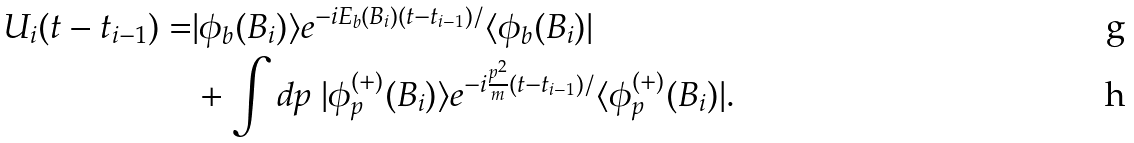Convert formula to latex. <formula><loc_0><loc_0><loc_500><loc_500>U _ { i } ( t - t _ { i - 1 } ) = & | \phi _ { b } ( B _ { i } ) \rangle e ^ { - i E _ { b } ( B _ { i } ) ( t - t _ { i - 1 } ) / } \langle \phi _ { b } ( B _ { i } ) | \\ & + \int d p \ | \phi _ { p } ^ { ( + ) } ( B _ { i } ) \rangle e ^ { - i \frac { p ^ { 2 } } { m } ( t - t _ { i - 1 } ) / } \langle \phi _ { p } ^ { ( + ) } ( B _ { i } ) | .</formula> 